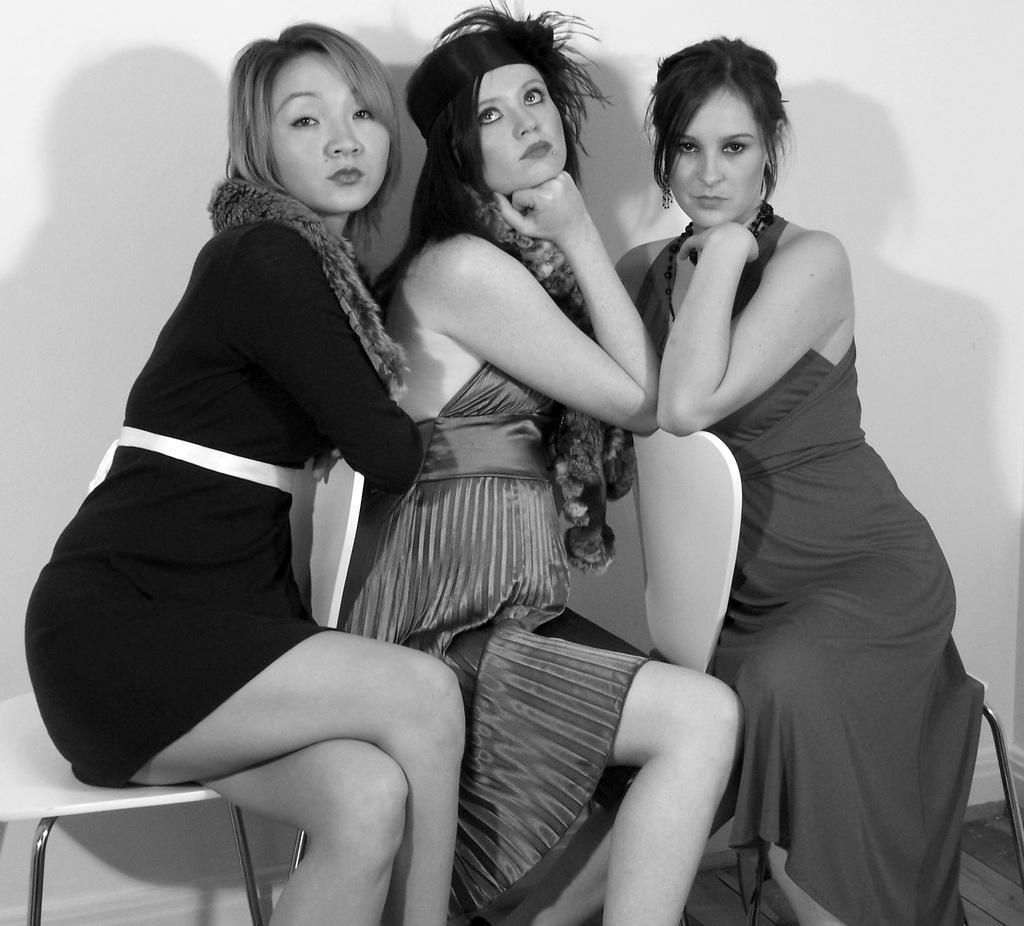Could you give a brief overview of what you see in this image? In this picture I can observe three women sitting in the chairs. This is a black and white image. In the background there is a wall. 